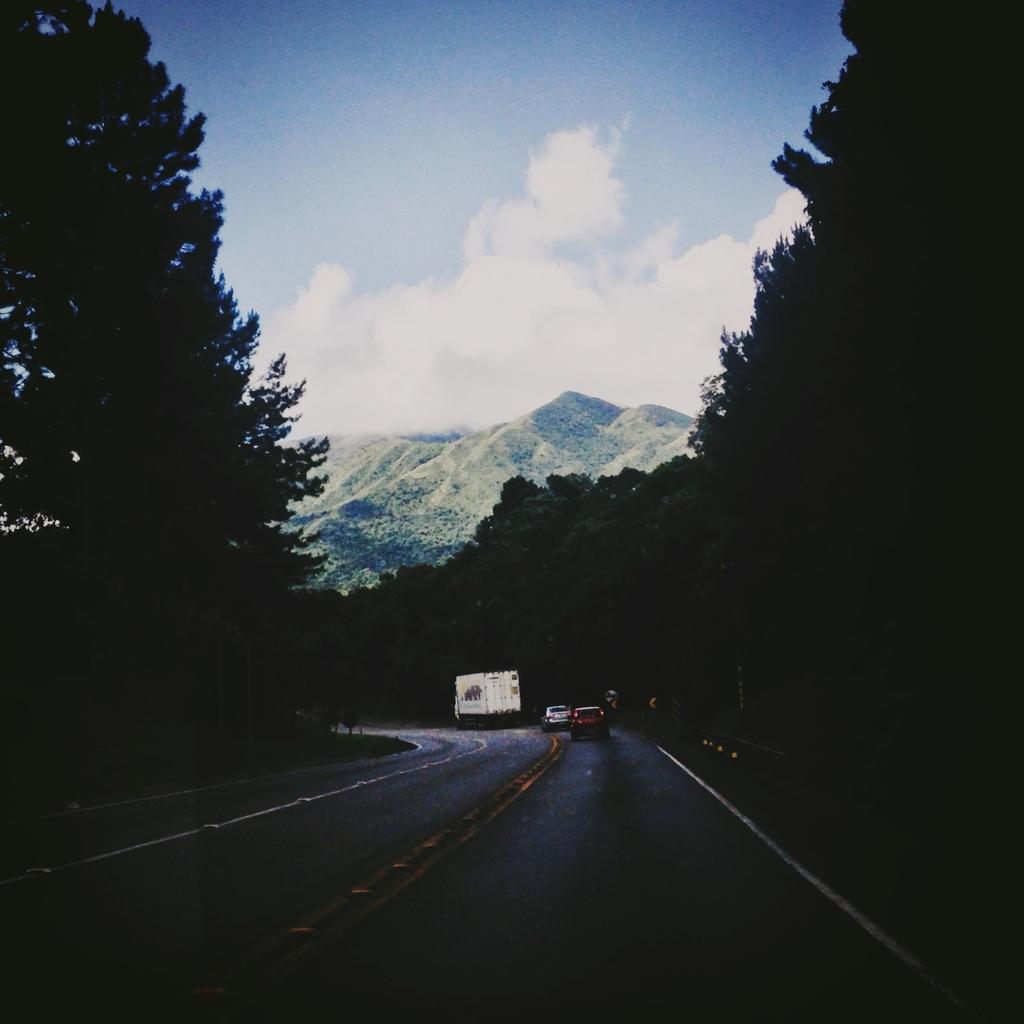What is the main feature of the image? There is a road in the image. What can be seen on the road? There are vehicles on the road. What surrounds the road in the image? There are many trees around the road. What can be seen in the distance in the image? There is a mountain visible in the background. Are there any dinosaurs visible on the road in the image? No, there are no dinosaurs present in the image. 